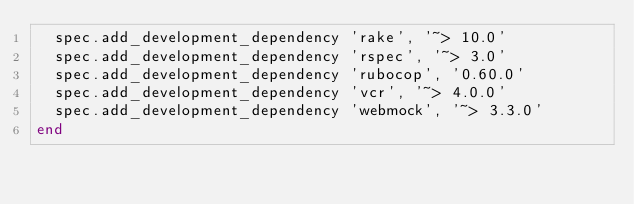<code> <loc_0><loc_0><loc_500><loc_500><_Ruby_>  spec.add_development_dependency 'rake', '~> 10.0'
  spec.add_development_dependency 'rspec', '~> 3.0'
  spec.add_development_dependency 'rubocop', '0.60.0'
  spec.add_development_dependency 'vcr', '~> 4.0.0'
  spec.add_development_dependency 'webmock', '~> 3.3.0'
end
</code> 